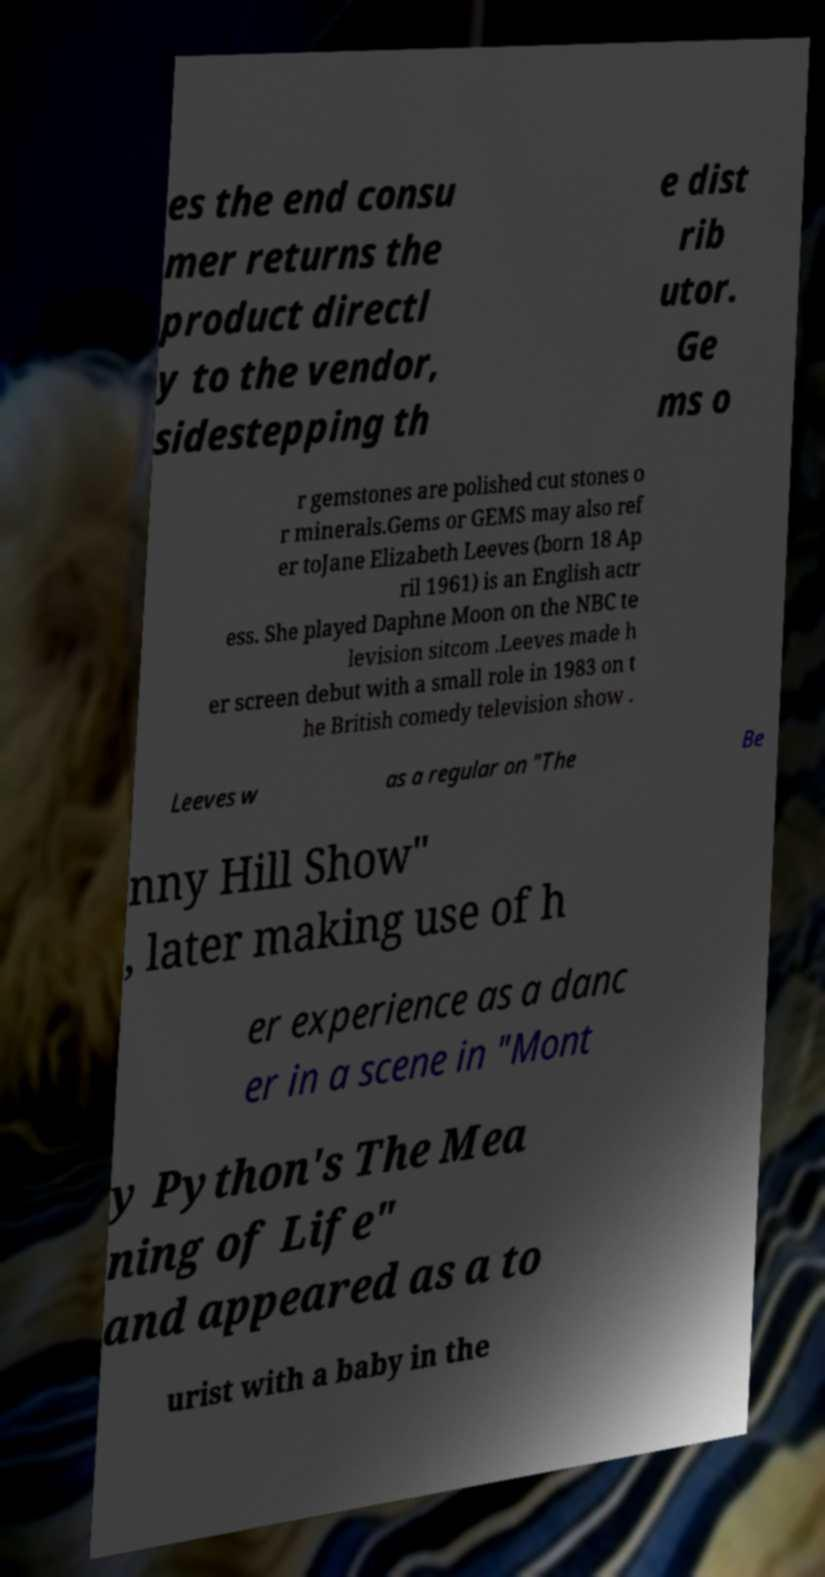Can you accurately transcribe the text from the provided image for me? es the end consu mer returns the product directl y to the vendor, sidestepping th e dist rib utor. Ge ms o r gemstones are polished cut stones o r minerals.Gems or GEMS may also ref er toJane Elizabeth Leeves (born 18 Ap ril 1961) is an English actr ess. She played Daphne Moon on the NBC te levision sitcom .Leeves made h er screen debut with a small role in 1983 on t he British comedy television show . Leeves w as a regular on "The Be nny Hill Show" , later making use of h er experience as a danc er in a scene in "Mont y Python's The Mea ning of Life" and appeared as a to urist with a baby in the 